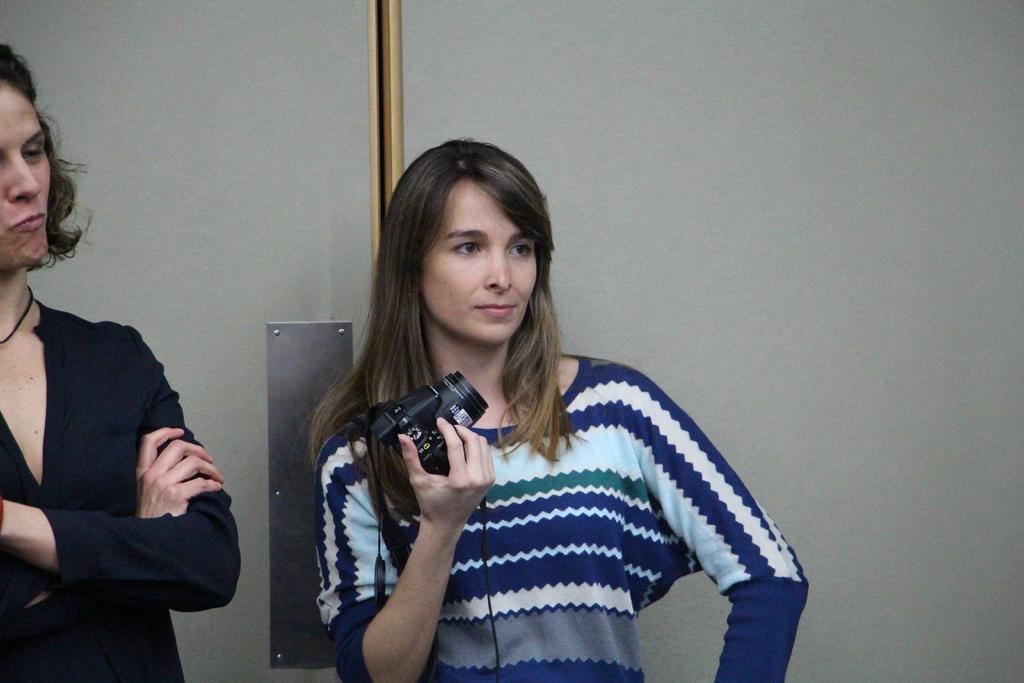Describe this image in one or two sentences. As we can see in the image, there are two persons standing and the women on the right side is holding camera in her hand. 